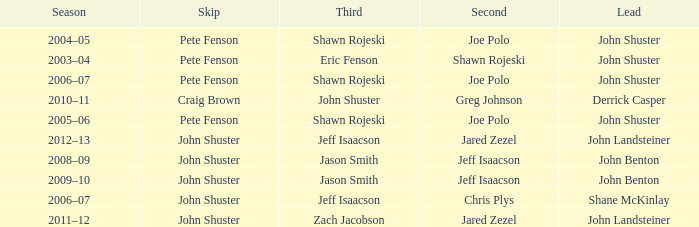Who was second when Shane McKinlay was the lead? Chris Plys. 